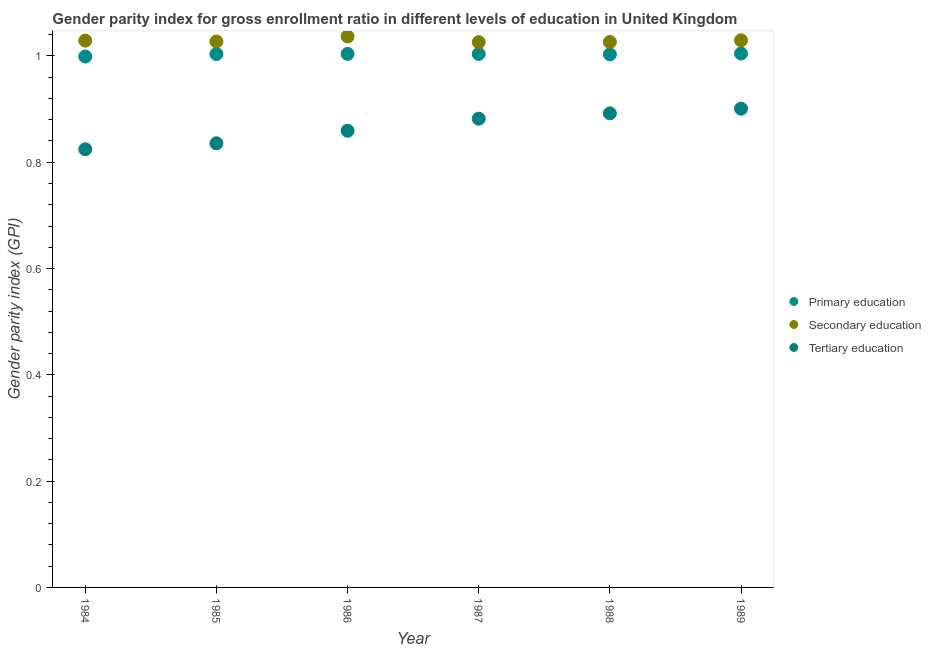How many different coloured dotlines are there?
Your response must be concise. 3. What is the gender parity index in tertiary education in 1987?
Ensure brevity in your answer.  0.88. Across all years, what is the maximum gender parity index in tertiary education?
Offer a terse response. 0.9. Across all years, what is the minimum gender parity index in tertiary education?
Provide a short and direct response. 0.82. In which year was the gender parity index in secondary education maximum?
Your response must be concise. 1986. In which year was the gender parity index in primary education minimum?
Provide a short and direct response. 1984. What is the total gender parity index in primary education in the graph?
Give a very brief answer. 6.02. What is the difference between the gender parity index in tertiary education in 1988 and that in 1989?
Provide a succinct answer. -0.01. What is the difference between the gender parity index in secondary education in 1989 and the gender parity index in tertiary education in 1986?
Offer a very short reply. 0.17. What is the average gender parity index in secondary education per year?
Make the answer very short. 1.03. In the year 1989, what is the difference between the gender parity index in tertiary education and gender parity index in secondary education?
Ensure brevity in your answer.  -0.13. In how many years, is the gender parity index in tertiary education greater than 0.8400000000000001?
Keep it short and to the point. 4. What is the ratio of the gender parity index in primary education in 1985 to that in 1988?
Make the answer very short. 1. Is the gender parity index in tertiary education in 1984 less than that in 1989?
Offer a very short reply. Yes. What is the difference between the highest and the second highest gender parity index in secondary education?
Give a very brief answer. 0.01. What is the difference between the highest and the lowest gender parity index in primary education?
Offer a terse response. 0.01. In how many years, is the gender parity index in primary education greater than the average gender parity index in primary education taken over all years?
Make the answer very short. 5. Is the sum of the gender parity index in secondary education in 1984 and 1985 greater than the maximum gender parity index in tertiary education across all years?
Make the answer very short. Yes. Is the gender parity index in secondary education strictly greater than the gender parity index in primary education over the years?
Provide a short and direct response. Yes. Is the gender parity index in secondary education strictly less than the gender parity index in primary education over the years?
Keep it short and to the point. No. How many dotlines are there?
Ensure brevity in your answer.  3. Does the graph contain any zero values?
Your response must be concise. No. Where does the legend appear in the graph?
Your answer should be compact. Center right. What is the title of the graph?
Ensure brevity in your answer.  Gender parity index for gross enrollment ratio in different levels of education in United Kingdom. What is the label or title of the X-axis?
Keep it short and to the point. Year. What is the label or title of the Y-axis?
Provide a succinct answer. Gender parity index (GPI). What is the Gender parity index (GPI) of Primary education in 1984?
Provide a succinct answer. 1. What is the Gender parity index (GPI) of Secondary education in 1984?
Offer a terse response. 1.03. What is the Gender parity index (GPI) in Tertiary education in 1984?
Your answer should be compact. 0.82. What is the Gender parity index (GPI) in Primary education in 1985?
Provide a succinct answer. 1. What is the Gender parity index (GPI) in Secondary education in 1985?
Your answer should be compact. 1.03. What is the Gender parity index (GPI) of Tertiary education in 1985?
Provide a succinct answer. 0.84. What is the Gender parity index (GPI) in Primary education in 1986?
Give a very brief answer. 1. What is the Gender parity index (GPI) of Secondary education in 1986?
Your answer should be compact. 1.04. What is the Gender parity index (GPI) of Tertiary education in 1986?
Provide a short and direct response. 0.86. What is the Gender parity index (GPI) in Primary education in 1987?
Provide a succinct answer. 1. What is the Gender parity index (GPI) of Secondary education in 1987?
Your answer should be compact. 1.03. What is the Gender parity index (GPI) in Tertiary education in 1987?
Ensure brevity in your answer.  0.88. What is the Gender parity index (GPI) in Primary education in 1988?
Give a very brief answer. 1. What is the Gender parity index (GPI) of Secondary education in 1988?
Ensure brevity in your answer.  1.03. What is the Gender parity index (GPI) in Tertiary education in 1988?
Offer a very short reply. 0.89. What is the Gender parity index (GPI) in Primary education in 1989?
Keep it short and to the point. 1. What is the Gender parity index (GPI) of Secondary education in 1989?
Provide a short and direct response. 1.03. What is the Gender parity index (GPI) of Tertiary education in 1989?
Offer a very short reply. 0.9. Across all years, what is the maximum Gender parity index (GPI) of Primary education?
Give a very brief answer. 1. Across all years, what is the maximum Gender parity index (GPI) in Secondary education?
Your answer should be very brief. 1.04. Across all years, what is the maximum Gender parity index (GPI) in Tertiary education?
Make the answer very short. 0.9. Across all years, what is the minimum Gender parity index (GPI) in Primary education?
Make the answer very short. 1. Across all years, what is the minimum Gender parity index (GPI) of Secondary education?
Your answer should be very brief. 1.03. Across all years, what is the minimum Gender parity index (GPI) in Tertiary education?
Ensure brevity in your answer.  0.82. What is the total Gender parity index (GPI) in Primary education in the graph?
Offer a terse response. 6.02. What is the total Gender parity index (GPI) of Secondary education in the graph?
Give a very brief answer. 6.17. What is the total Gender parity index (GPI) of Tertiary education in the graph?
Keep it short and to the point. 5.19. What is the difference between the Gender parity index (GPI) of Primary education in 1984 and that in 1985?
Keep it short and to the point. -0. What is the difference between the Gender parity index (GPI) of Secondary education in 1984 and that in 1985?
Your response must be concise. 0. What is the difference between the Gender parity index (GPI) in Tertiary education in 1984 and that in 1985?
Offer a very short reply. -0.01. What is the difference between the Gender parity index (GPI) of Primary education in 1984 and that in 1986?
Provide a short and direct response. -0.01. What is the difference between the Gender parity index (GPI) in Secondary education in 1984 and that in 1986?
Provide a succinct answer. -0.01. What is the difference between the Gender parity index (GPI) in Tertiary education in 1984 and that in 1986?
Keep it short and to the point. -0.03. What is the difference between the Gender parity index (GPI) of Primary education in 1984 and that in 1987?
Offer a terse response. -0. What is the difference between the Gender parity index (GPI) of Secondary education in 1984 and that in 1987?
Offer a terse response. 0. What is the difference between the Gender parity index (GPI) in Tertiary education in 1984 and that in 1987?
Provide a succinct answer. -0.06. What is the difference between the Gender parity index (GPI) in Primary education in 1984 and that in 1988?
Offer a terse response. -0. What is the difference between the Gender parity index (GPI) of Secondary education in 1984 and that in 1988?
Provide a short and direct response. 0. What is the difference between the Gender parity index (GPI) in Tertiary education in 1984 and that in 1988?
Provide a succinct answer. -0.07. What is the difference between the Gender parity index (GPI) in Primary education in 1984 and that in 1989?
Offer a terse response. -0.01. What is the difference between the Gender parity index (GPI) in Secondary education in 1984 and that in 1989?
Ensure brevity in your answer.  -0. What is the difference between the Gender parity index (GPI) in Tertiary education in 1984 and that in 1989?
Provide a short and direct response. -0.08. What is the difference between the Gender parity index (GPI) in Primary education in 1985 and that in 1986?
Give a very brief answer. -0. What is the difference between the Gender parity index (GPI) of Secondary education in 1985 and that in 1986?
Make the answer very short. -0.01. What is the difference between the Gender parity index (GPI) of Tertiary education in 1985 and that in 1986?
Make the answer very short. -0.02. What is the difference between the Gender parity index (GPI) in Primary education in 1985 and that in 1987?
Keep it short and to the point. -0. What is the difference between the Gender parity index (GPI) in Secondary education in 1985 and that in 1987?
Ensure brevity in your answer.  0. What is the difference between the Gender parity index (GPI) of Tertiary education in 1985 and that in 1987?
Your response must be concise. -0.05. What is the difference between the Gender parity index (GPI) in Primary education in 1985 and that in 1988?
Keep it short and to the point. 0. What is the difference between the Gender parity index (GPI) in Secondary education in 1985 and that in 1988?
Give a very brief answer. 0. What is the difference between the Gender parity index (GPI) in Tertiary education in 1985 and that in 1988?
Provide a short and direct response. -0.06. What is the difference between the Gender parity index (GPI) of Primary education in 1985 and that in 1989?
Provide a succinct answer. -0. What is the difference between the Gender parity index (GPI) in Secondary education in 1985 and that in 1989?
Your response must be concise. -0. What is the difference between the Gender parity index (GPI) of Tertiary education in 1985 and that in 1989?
Your answer should be very brief. -0.07. What is the difference between the Gender parity index (GPI) of Secondary education in 1986 and that in 1987?
Your answer should be compact. 0.01. What is the difference between the Gender parity index (GPI) in Tertiary education in 1986 and that in 1987?
Provide a succinct answer. -0.02. What is the difference between the Gender parity index (GPI) in Primary education in 1986 and that in 1988?
Give a very brief answer. 0. What is the difference between the Gender parity index (GPI) of Secondary education in 1986 and that in 1988?
Offer a terse response. 0.01. What is the difference between the Gender parity index (GPI) of Tertiary education in 1986 and that in 1988?
Provide a succinct answer. -0.03. What is the difference between the Gender parity index (GPI) of Primary education in 1986 and that in 1989?
Your answer should be very brief. -0. What is the difference between the Gender parity index (GPI) in Secondary education in 1986 and that in 1989?
Ensure brevity in your answer.  0.01. What is the difference between the Gender parity index (GPI) of Tertiary education in 1986 and that in 1989?
Give a very brief answer. -0.04. What is the difference between the Gender parity index (GPI) in Primary education in 1987 and that in 1988?
Offer a very short reply. 0. What is the difference between the Gender parity index (GPI) in Secondary education in 1987 and that in 1988?
Your answer should be compact. -0. What is the difference between the Gender parity index (GPI) of Tertiary education in 1987 and that in 1988?
Provide a short and direct response. -0.01. What is the difference between the Gender parity index (GPI) of Primary education in 1987 and that in 1989?
Make the answer very short. -0. What is the difference between the Gender parity index (GPI) of Secondary education in 1987 and that in 1989?
Your response must be concise. -0. What is the difference between the Gender parity index (GPI) in Tertiary education in 1987 and that in 1989?
Make the answer very short. -0.02. What is the difference between the Gender parity index (GPI) in Primary education in 1988 and that in 1989?
Keep it short and to the point. -0. What is the difference between the Gender parity index (GPI) in Secondary education in 1988 and that in 1989?
Provide a short and direct response. -0. What is the difference between the Gender parity index (GPI) of Tertiary education in 1988 and that in 1989?
Make the answer very short. -0.01. What is the difference between the Gender parity index (GPI) in Primary education in 1984 and the Gender parity index (GPI) in Secondary education in 1985?
Your response must be concise. -0.03. What is the difference between the Gender parity index (GPI) of Primary education in 1984 and the Gender parity index (GPI) of Tertiary education in 1985?
Give a very brief answer. 0.16. What is the difference between the Gender parity index (GPI) of Secondary education in 1984 and the Gender parity index (GPI) of Tertiary education in 1985?
Make the answer very short. 0.19. What is the difference between the Gender parity index (GPI) of Primary education in 1984 and the Gender parity index (GPI) of Secondary education in 1986?
Provide a succinct answer. -0.04. What is the difference between the Gender parity index (GPI) in Primary education in 1984 and the Gender parity index (GPI) in Tertiary education in 1986?
Give a very brief answer. 0.14. What is the difference between the Gender parity index (GPI) of Secondary education in 1984 and the Gender parity index (GPI) of Tertiary education in 1986?
Keep it short and to the point. 0.17. What is the difference between the Gender parity index (GPI) of Primary education in 1984 and the Gender parity index (GPI) of Secondary education in 1987?
Give a very brief answer. -0.03. What is the difference between the Gender parity index (GPI) of Primary education in 1984 and the Gender parity index (GPI) of Tertiary education in 1987?
Ensure brevity in your answer.  0.12. What is the difference between the Gender parity index (GPI) in Secondary education in 1984 and the Gender parity index (GPI) in Tertiary education in 1987?
Provide a short and direct response. 0.15. What is the difference between the Gender parity index (GPI) of Primary education in 1984 and the Gender parity index (GPI) of Secondary education in 1988?
Offer a very short reply. -0.03. What is the difference between the Gender parity index (GPI) in Primary education in 1984 and the Gender parity index (GPI) in Tertiary education in 1988?
Your answer should be very brief. 0.11. What is the difference between the Gender parity index (GPI) of Secondary education in 1984 and the Gender parity index (GPI) of Tertiary education in 1988?
Make the answer very short. 0.14. What is the difference between the Gender parity index (GPI) of Primary education in 1984 and the Gender parity index (GPI) of Secondary education in 1989?
Your answer should be compact. -0.03. What is the difference between the Gender parity index (GPI) in Primary education in 1984 and the Gender parity index (GPI) in Tertiary education in 1989?
Provide a succinct answer. 0.1. What is the difference between the Gender parity index (GPI) in Secondary education in 1984 and the Gender parity index (GPI) in Tertiary education in 1989?
Make the answer very short. 0.13. What is the difference between the Gender parity index (GPI) in Primary education in 1985 and the Gender parity index (GPI) in Secondary education in 1986?
Give a very brief answer. -0.03. What is the difference between the Gender parity index (GPI) of Primary education in 1985 and the Gender parity index (GPI) of Tertiary education in 1986?
Ensure brevity in your answer.  0.14. What is the difference between the Gender parity index (GPI) of Secondary education in 1985 and the Gender parity index (GPI) of Tertiary education in 1986?
Provide a succinct answer. 0.17. What is the difference between the Gender parity index (GPI) in Primary education in 1985 and the Gender parity index (GPI) in Secondary education in 1987?
Offer a terse response. -0.02. What is the difference between the Gender parity index (GPI) in Primary education in 1985 and the Gender parity index (GPI) in Tertiary education in 1987?
Your response must be concise. 0.12. What is the difference between the Gender parity index (GPI) in Secondary education in 1985 and the Gender parity index (GPI) in Tertiary education in 1987?
Offer a terse response. 0.15. What is the difference between the Gender parity index (GPI) of Primary education in 1985 and the Gender parity index (GPI) of Secondary education in 1988?
Give a very brief answer. -0.02. What is the difference between the Gender parity index (GPI) in Primary education in 1985 and the Gender parity index (GPI) in Tertiary education in 1988?
Your response must be concise. 0.11. What is the difference between the Gender parity index (GPI) in Secondary education in 1985 and the Gender parity index (GPI) in Tertiary education in 1988?
Offer a very short reply. 0.14. What is the difference between the Gender parity index (GPI) of Primary education in 1985 and the Gender parity index (GPI) of Secondary education in 1989?
Your answer should be very brief. -0.03. What is the difference between the Gender parity index (GPI) in Primary education in 1985 and the Gender parity index (GPI) in Tertiary education in 1989?
Provide a short and direct response. 0.1. What is the difference between the Gender parity index (GPI) in Secondary education in 1985 and the Gender parity index (GPI) in Tertiary education in 1989?
Keep it short and to the point. 0.13. What is the difference between the Gender parity index (GPI) of Primary education in 1986 and the Gender parity index (GPI) of Secondary education in 1987?
Keep it short and to the point. -0.02. What is the difference between the Gender parity index (GPI) in Primary education in 1986 and the Gender parity index (GPI) in Tertiary education in 1987?
Your answer should be compact. 0.12. What is the difference between the Gender parity index (GPI) in Secondary education in 1986 and the Gender parity index (GPI) in Tertiary education in 1987?
Offer a terse response. 0.15. What is the difference between the Gender parity index (GPI) of Primary education in 1986 and the Gender parity index (GPI) of Secondary education in 1988?
Your answer should be compact. -0.02. What is the difference between the Gender parity index (GPI) of Primary education in 1986 and the Gender parity index (GPI) of Tertiary education in 1988?
Keep it short and to the point. 0.11. What is the difference between the Gender parity index (GPI) of Secondary education in 1986 and the Gender parity index (GPI) of Tertiary education in 1988?
Offer a very short reply. 0.14. What is the difference between the Gender parity index (GPI) in Primary education in 1986 and the Gender parity index (GPI) in Secondary education in 1989?
Keep it short and to the point. -0.03. What is the difference between the Gender parity index (GPI) of Primary education in 1986 and the Gender parity index (GPI) of Tertiary education in 1989?
Give a very brief answer. 0.1. What is the difference between the Gender parity index (GPI) in Secondary education in 1986 and the Gender parity index (GPI) in Tertiary education in 1989?
Your response must be concise. 0.14. What is the difference between the Gender parity index (GPI) in Primary education in 1987 and the Gender parity index (GPI) in Secondary education in 1988?
Make the answer very short. -0.02. What is the difference between the Gender parity index (GPI) in Primary education in 1987 and the Gender parity index (GPI) in Tertiary education in 1988?
Your response must be concise. 0.11. What is the difference between the Gender parity index (GPI) in Secondary education in 1987 and the Gender parity index (GPI) in Tertiary education in 1988?
Make the answer very short. 0.13. What is the difference between the Gender parity index (GPI) in Primary education in 1987 and the Gender parity index (GPI) in Secondary education in 1989?
Make the answer very short. -0.03. What is the difference between the Gender parity index (GPI) of Primary education in 1987 and the Gender parity index (GPI) of Tertiary education in 1989?
Ensure brevity in your answer.  0.1. What is the difference between the Gender parity index (GPI) in Secondary education in 1987 and the Gender parity index (GPI) in Tertiary education in 1989?
Provide a succinct answer. 0.13. What is the difference between the Gender parity index (GPI) in Primary education in 1988 and the Gender parity index (GPI) in Secondary education in 1989?
Give a very brief answer. -0.03. What is the difference between the Gender parity index (GPI) in Primary education in 1988 and the Gender parity index (GPI) in Tertiary education in 1989?
Ensure brevity in your answer.  0.1. What is the difference between the Gender parity index (GPI) of Secondary education in 1988 and the Gender parity index (GPI) of Tertiary education in 1989?
Your answer should be very brief. 0.13. What is the average Gender parity index (GPI) of Tertiary education per year?
Offer a terse response. 0.87. In the year 1984, what is the difference between the Gender parity index (GPI) of Primary education and Gender parity index (GPI) of Secondary education?
Provide a succinct answer. -0.03. In the year 1984, what is the difference between the Gender parity index (GPI) of Primary education and Gender parity index (GPI) of Tertiary education?
Provide a short and direct response. 0.17. In the year 1984, what is the difference between the Gender parity index (GPI) of Secondary education and Gender parity index (GPI) of Tertiary education?
Keep it short and to the point. 0.2. In the year 1985, what is the difference between the Gender parity index (GPI) in Primary education and Gender parity index (GPI) in Secondary education?
Offer a terse response. -0.02. In the year 1985, what is the difference between the Gender parity index (GPI) in Primary education and Gender parity index (GPI) in Tertiary education?
Provide a succinct answer. 0.17. In the year 1985, what is the difference between the Gender parity index (GPI) in Secondary education and Gender parity index (GPI) in Tertiary education?
Offer a terse response. 0.19. In the year 1986, what is the difference between the Gender parity index (GPI) of Primary education and Gender parity index (GPI) of Secondary education?
Provide a short and direct response. -0.03. In the year 1986, what is the difference between the Gender parity index (GPI) in Primary education and Gender parity index (GPI) in Tertiary education?
Offer a very short reply. 0.14. In the year 1986, what is the difference between the Gender parity index (GPI) of Secondary education and Gender parity index (GPI) of Tertiary education?
Your answer should be very brief. 0.18. In the year 1987, what is the difference between the Gender parity index (GPI) in Primary education and Gender parity index (GPI) in Secondary education?
Your response must be concise. -0.02. In the year 1987, what is the difference between the Gender parity index (GPI) in Primary education and Gender parity index (GPI) in Tertiary education?
Provide a succinct answer. 0.12. In the year 1987, what is the difference between the Gender parity index (GPI) in Secondary education and Gender parity index (GPI) in Tertiary education?
Provide a short and direct response. 0.14. In the year 1988, what is the difference between the Gender parity index (GPI) of Primary education and Gender parity index (GPI) of Secondary education?
Your answer should be compact. -0.02. In the year 1988, what is the difference between the Gender parity index (GPI) of Primary education and Gender parity index (GPI) of Tertiary education?
Make the answer very short. 0.11. In the year 1988, what is the difference between the Gender parity index (GPI) in Secondary education and Gender parity index (GPI) in Tertiary education?
Your response must be concise. 0.13. In the year 1989, what is the difference between the Gender parity index (GPI) in Primary education and Gender parity index (GPI) in Secondary education?
Your response must be concise. -0.03. In the year 1989, what is the difference between the Gender parity index (GPI) in Primary education and Gender parity index (GPI) in Tertiary education?
Give a very brief answer. 0.1. In the year 1989, what is the difference between the Gender parity index (GPI) of Secondary education and Gender parity index (GPI) of Tertiary education?
Ensure brevity in your answer.  0.13. What is the ratio of the Gender parity index (GPI) of Tertiary education in 1984 to that in 1985?
Offer a terse response. 0.99. What is the ratio of the Gender parity index (GPI) in Primary education in 1984 to that in 1986?
Offer a terse response. 0.99. What is the ratio of the Gender parity index (GPI) of Secondary education in 1984 to that in 1986?
Offer a terse response. 0.99. What is the ratio of the Gender parity index (GPI) of Tertiary education in 1984 to that in 1986?
Give a very brief answer. 0.96. What is the ratio of the Gender parity index (GPI) of Secondary education in 1984 to that in 1987?
Keep it short and to the point. 1. What is the ratio of the Gender parity index (GPI) of Tertiary education in 1984 to that in 1987?
Ensure brevity in your answer.  0.93. What is the ratio of the Gender parity index (GPI) of Primary education in 1984 to that in 1988?
Make the answer very short. 1. What is the ratio of the Gender parity index (GPI) in Tertiary education in 1984 to that in 1988?
Offer a terse response. 0.92. What is the ratio of the Gender parity index (GPI) in Primary education in 1984 to that in 1989?
Offer a very short reply. 0.99. What is the ratio of the Gender parity index (GPI) in Tertiary education in 1984 to that in 1989?
Your answer should be very brief. 0.92. What is the ratio of the Gender parity index (GPI) in Secondary education in 1985 to that in 1986?
Your answer should be compact. 0.99. What is the ratio of the Gender parity index (GPI) in Tertiary education in 1985 to that in 1986?
Your response must be concise. 0.97. What is the ratio of the Gender parity index (GPI) in Primary education in 1985 to that in 1987?
Provide a succinct answer. 1. What is the ratio of the Gender parity index (GPI) of Secondary education in 1985 to that in 1987?
Offer a very short reply. 1. What is the ratio of the Gender parity index (GPI) in Tertiary education in 1985 to that in 1987?
Provide a succinct answer. 0.95. What is the ratio of the Gender parity index (GPI) in Primary education in 1985 to that in 1988?
Provide a succinct answer. 1. What is the ratio of the Gender parity index (GPI) of Tertiary education in 1985 to that in 1988?
Make the answer very short. 0.94. What is the ratio of the Gender parity index (GPI) in Secondary education in 1985 to that in 1989?
Give a very brief answer. 1. What is the ratio of the Gender parity index (GPI) in Tertiary education in 1985 to that in 1989?
Provide a succinct answer. 0.93. What is the ratio of the Gender parity index (GPI) of Primary education in 1986 to that in 1987?
Keep it short and to the point. 1. What is the ratio of the Gender parity index (GPI) in Secondary education in 1986 to that in 1987?
Keep it short and to the point. 1.01. What is the ratio of the Gender parity index (GPI) of Tertiary education in 1986 to that in 1987?
Provide a succinct answer. 0.97. What is the ratio of the Gender parity index (GPI) in Secondary education in 1986 to that in 1988?
Ensure brevity in your answer.  1.01. What is the ratio of the Gender parity index (GPI) of Tertiary education in 1986 to that in 1988?
Make the answer very short. 0.96. What is the ratio of the Gender parity index (GPI) of Primary education in 1986 to that in 1989?
Offer a terse response. 1. What is the ratio of the Gender parity index (GPI) in Tertiary education in 1986 to that in 1989?
Ensure brevity in your answer.  0.95. What is the ratio of the Gender parity index (GPI) in Primary education in 1987 to that in 1988?
Your answer should be very brief. 1. What is the ratio of the Gender parity index (GPI) of Tertiary education in 1987 to that in 1988?
Give a very brief answer. 0.99. What is the ratio of the Gender parity index (GPI) of Secondary education in 1987 to that in 1989?
Your answer should be very brief. 1. What is the difference between the highest and the second highest Gender parity index (GPI) of Primary education?
Give a very brief answer. 0. What is the difference between the highest and the second highest Gender parity index (GPI) in Secondary education?
Your response must be concise. 0.01. What is the difference between the highest and the second highest Gender parity index (GPI) in Tertiary education?
Make the answer very short. 0.01. What is the difference between the highest and the lowest Gender parity index (GPI) of Primary education?
Your answer should be very brief. 0.01. What is the difference between the highest and the lowest Gender parity index (GPI) in Secondary education?
Make the answer very short. 0.01. What is the difference between the highest and the lowest Gender parity index (GPI) of Tertiary education?
Provide a succinct answer. 0.08. 